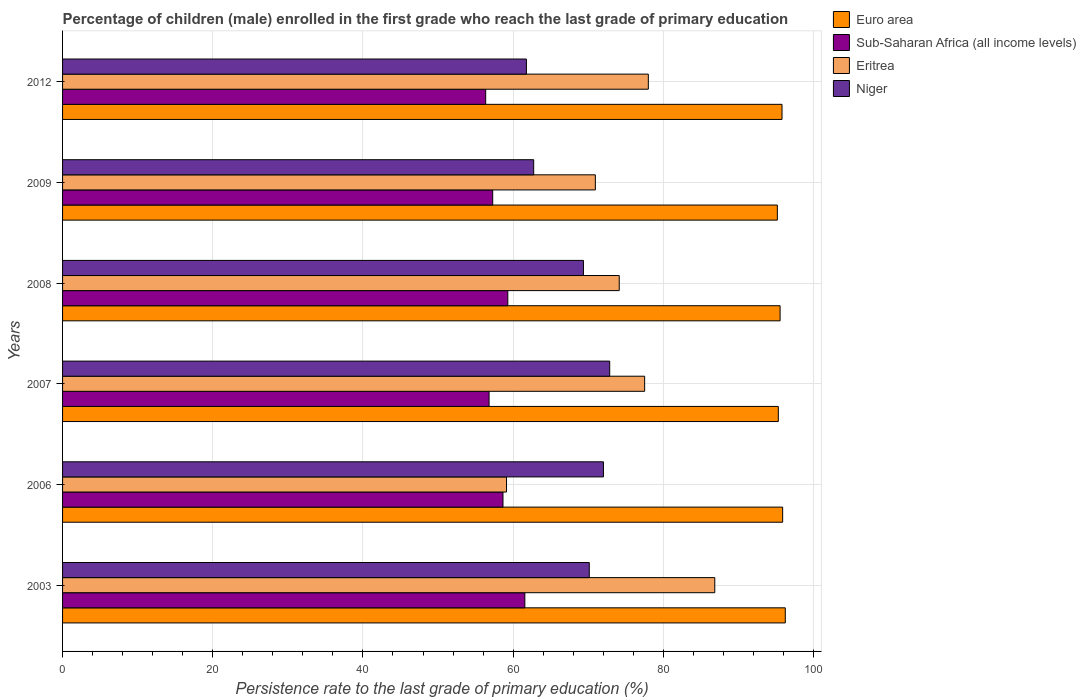How many groups of bars are there?
Your answer should be very brief. 6. Are the number of bars per tick equal to the number of legend labels?
Keep it short and to the point. Yes. How many bars are there on the 4th tick from the top?
Make the answer very short. 4. How many bars are there on the 4th tick from the bottom?
Your answer should be compact. 4. In how many cases, is the number of bars for a given year not equal to the number of legend labels?
Ensure brevity in your answer.  0. What is the persistence rate of children in Sub-Saharan Africa (all income levels) in 2009?
Offer a very short reply. 57.28. Across all years, what is the maximum persistence rate of children in Niger?
Offer a terse response. 72.86. Across all years, what is the minimum persistence rate of children in Euro area?
Offer a very short reply. 95.18. In which year was the persistence rate of children in Eritrea maximum?
Your answer should be compact. 2003. What is the total persistence rate of children in Euro area in the graph?
Your response must be concise. 573.97. What is the difference between the persistence rate of children in Sub-Saharan Africa (all income levels) in 2008 and that in 2009?
Your answer should be compact. 2.01. What is the difference between the persistence rate of children in Sub-Saharan Africa (all income levels) in 2006 and the persistence rate of children in Niger in 2008?
Your answer should be compact. -10.71. What is the average persistence rate of children in Niger per year?
Your answer should be compact. 68.15. In the year 2012, what is the difference between the persistence rate of children in Eritrea and persistence rate of children in Niger?
Your answer should be very brief. 16.23. What is the ratio of the persistence rate of children in Euro area in 2008 to that in 2012?
Offer a terse response. 1. Is the persistence rate of children in Euro area in 2007 less than that in 2008?
Provide a short and direct response. Yes. What is the difference between the highest and the second highest persistence rate of children in Niger?
Make the answer very short. 0.84. What is the difference between the highest and the lowest persistence rate of children in Niger?
Your answer should be compact. 11.09. In how many years, is the persistence rate of children in Niger greater than the average persistence rate of children in Niger taken over all years?
Ensure brevity in your answer.  4. Is the sum of the persistence rate of children in Sub-Saharan Africa (all income levels) in 2006 and 2012 greater than the maximum persistence rate of children in Euro area across all years?
Provide a short and direct response. Yes. Is it the case that in every year, the sum of the persistence rate of children in Eritrea and persistence rate of children in Euro area is greater than the sum of persistence rate of children in Niger and persistence rate of children in Sub-Saharan Africa (all income levels)?
Provide a succinct answer. Yes. What does the 2nd bar from the top in 2006 represents?
Give a very brief answer. Eritrea. What does the 2nd bar from the bottom in 2009 represents?
Provide a short and direct response. Sub-Saharan Africa (all income levels). Is it the case that in every year, the sum of the persistence rate of children in Sub-Saharan Africa (all income levels) and persistence rate of children in Niger is greater than the persistence rate of children in Eritrea?
Give a very brief answer. Yes. What is the difference between two consecutive major ticks on the X-axis?
Offer a very short reply. 20. Does the graph contain any zero values?
Your answer should be compact. No. How are the legend labels stacked?
Provide a short and direct response. Vertical. What is the title of the graph?
Your response must be concise. Percentage of children (male) enrolled in the first grade who reach the last grade of primary education. What is the label or title of the X-axis?
Your answer should be compact. Persistence rate to the last grade of primary education (%). What is the label or title of the Y-axis?
Provide a succinct answer. Years. What is the Persistence rate to the last grade of primary education (%) in Euro area in 2003?
Provide a succinct answer. 96.24. What is the Persistence rate to the last grade of primary education (%) of Sub-Saharan Africa (all income levels) in 2003?
Ensure brevity in your answer.  61.56. What is the Persistence rate to the last grade of primary education (%) in Eritrea in 2003?
Make the answer very short. 86.85. What is the Persistence rate to the last grade of primary education (%) of Niger in 2003?
Give a very brief answer. 70.14. What is the Persistence rate to the last grade of primary education (%) of Euro area in 2006?
Your answer should be very brief. 95.89. What is the Persistence rate to the last grade of primary education (%) in Sub-Saharan Africa (all income levels) in 2006?
Your answer should be very brief. 58.65. What is the Persistence rate to the last grade of primary education (%) in Eritrea in 2006?
Provide a succinct answer. 59.12. What is the Persistence rate to the last grade of primary education (%) of Niger in 2006?
Ensure brevity in your answer.  72.02. What is the Persistence rate to the last grade of primary education (%) in Euro area in 2007?
Provide a succinct answer. 95.31. What is the Persistence rate to the last grade of primary education (%) of Sub-Saharan Africa (all income levels) in 2007?
Offer a terse response. 56.8. What is the Persistence rate to the last grade of primary education (%) of Eritrea in 2007?
Keep it short and to the point. 77.51. What is the Persistence rate to the last grade of primary education (%) of Niger in 2007?
Your response must be concise. 72.86. What is the Persistence rate to the last grade of primary education (%) of Euro area in 2008?
Offer a very short reply. 95.55. What is the Persistence rate to the last grade of primary education (%) in Sub-Saharan Africa (all income levels) in 2008?
Your answer should be compact. 59.29. What is the Persistence rate to the last grade of primary education (%) in Eritrea in 2008?
Provide a succinct answer. 74.13. What is the Persistence rate to the last grade of primary education (%) of Niger in 2008?
Your answer should be very brief. 69.36. What is the Persistence rate to the last grade of primary education (%) of Euro area in 2009?
Provide a succinct answer. 95.18. What is the Persistence rate to the last grade of primary education (%) of Sub-Saharan Africa (all income levels) in 2009?
Provide a short and direct response. 57.28. What is the Persistence rate to the last grade of primary education (%) in Eritrea in 2009?
Offer a very short reply. 70.95. What is the Persistence rate to the last grade of primary education (%) in Niger in 2009?
Keep it short and to the point. 62.73. What is the Persistence rate to the last grade of primary education (%) of Euro area in 2012?
Your response must be concise. 95.8. What is the Persistence rate to the last grade of primary education (%) in Sub-Saharan Africa (all income levels) in 2012?
Offer a very short reply. 56.34. What is the Persistence rate to the last grade of primary education (%) in Eritrea in 2012?
Offer a very short reply. 78. What is the Persistence rate to the last grade of primary education (%) in Niger in 2012?
Your answer should be very brief. 61.77. Across all years, what is the maximum Persistence rate to the last grade of primary education (%) of Euro area?
Give a very brief answer. 96.24. Across all years, what is the maximum Persistence rate to the last grade of primary education (%) of Sub-Saharan Africa (all income levels)?
Offer a very short reply. 61.56. Across all years, what is the maximum Persistence rate to the last grade of primary education (%) in Eritrea?
Give a very brief answer. 86.85. Across all years, what is the maximum Persistence rate to the last grade of primary education (%) of Niger?
Provide a succinct answer. 72.86. Across all years, what is the minimum Persistence rate to the last grade of primary education (%) of Euro area?
Ensure brevity in your answer.  95.18. Across all years, what is the minimum Persistence rate to the last grade of primary education (%) of Sub-Saharan Africa (all income levels)?
Offer a very short reply. 56.34. Across all years, what is the minimum Persistence rate to the last grade of primary education (%) in Eritrea?
Your answer should be very brief. 59.12. Across all years, what is the minimum Persistence rate to the last grade of primary education (%) of Niger?
Give a very brief answer. 61.77. What is the total Persistence rate to the last grade of primary education (%) of Euro area in the graph?
Give a very brief answer. 573.97. What is the total Persistence rate to the last grade of primary education (%) in Sub-Saharan Africa (all income levels) in the graph?
Give a very brief answer. 349.91. What is the total Persistence rate to the last grade of primary education (%) of Eritrea in the graph?
Your answer should be compact. 446.55. What is the total Persistence rate to the last grade of primary education (%) in Niger in the graph?
Your response must be concise. 408.88. What is the difference between the Persistence rate to the last grade of primary education (%) in Euro area in 2003 and that in 2006?
Your answer should be very brief. 0.35. What is the difference between the Persistence rate to the last grade of primary education (%) of Sub-Saharan Africa (all income levels) in 2003 and that in 2006?
Your answer should be compact. 2.91. What is the difference between the Persistence rate to the last grade of primary education (%) in Eritrea in 2003 and that in 2006?
Provide a short and direct response. 27.73. What is the difference between the Persistence rate to the last grade of primary education (%) in Niger in 2003 and that in 2006?
Offer a very short reply. -1.89. What is the difference between the Persistence rate to the last grade of primary education (%) in Euro area in 2003 and that in 2007?
Offer a very short reply. 0.93. What is the difference between the Persistence rate to the last grade of primary education (%) in Sub-Saharan Africa (all income levels) in 2003 and that in 2007?
Your response must be concise. 4.76. What is the difference between the Persistence rate to the last grade of primary education (%) of Eritrea in 2003 and that in 2007?
Provide a short and direct response. 9.34. What is the difference between the Persistence rate to the last grade of primary education (%) of Niger in 2003 and that in 2007?
Keep it short and to the point. -2.72. What is the difference between the Persistence rate to the last grade of primary education (%) in Euro area in 2003 and that in 2008?
Provide a succinct answer. 0.69. What is the difference between the Persistence rate to the last grade of primary education (%) in Sub-Saharan Africa (all income levels) in 2003 and that in 2008?
Your answer should be very brief. 2.27. What is the difference between the Persistence rate to the last grade of primary education (%) of Eritrea in 2003 and that in 2008?
Your response must be concise. 12.72. What is the difference between the Persistence rate to the last grade of primary education (%) of Niger in 2003 and that in 2008?
Ensure brevity in your answer.  0.78. What is the difference between the Persistence rate to the last grade of primary education (%) in Euro area in 2003 and that in 2009?
Your answer should be compact. 1.06. What is the difference between the Persistence rate to the last grade of primary education (%) in Sub-Saharan Africa (all income levels) in 2003 and that in 2009?
Offer a very short reply. 4.28. What is the difference between the Persistence rate to the last grade of primary education (%) in Eritrea in 2003 and that in 2009?
Your answer should be very brief. 15.9. What is the difference between the Persistence rate to the last grade of primary education (%) in Niger in 2003 and that in 2009?
Make the answer very short. 7.4. What is the difference between the Persistence rate to the last grade of primary education (%) of Euro area in 2003 and that in 2012?
Offer a terse response. 0.43. What is the difference between the Persistence rate to the last grade of primary education (%) in Sub-Saharan Africa (all income levels) in 2003 and that in 2012?
Make the answer very short. 5.21. What is the difference between the Persistence rate to the last grade of primary education (%) in Eritrea in 2003 and that in 2012?
Provide a succinct answer. 8.85. What is the difference between the Persistence rate to the last grade of primary education (%) of Niger in 2003 and that in 2012?
Ensure brevity in your answer.  8.37. What is the difference between the Persistence rate to the last grade of primary education (%) in Euro area in 2006 and that in 2007?
Offer a terse response. 0.58. What is the difference between the Persistence rate to the last grade of primary education (%) in Sub-Saharan Africa (all income levels) in 2006 and that in 2007?
Provide a succinct answer. 1.85. What is the difference between the Persistence rate to the last grade of primary education (%) of Eritrea in 2006 and that in 2007?
Your response must be concise. -18.39. What is the difference between the Persistence rate to the last grade of primary education (%) of Niger in 2006 and that in 2007?
Your response must be concise. -0.84. What is the difference between the Persistence rate to the last grade of primary education (%) of Euro area in 2006 and that in 2008?
Keep it short and to the point. 0.34. What is the difference between the Persistence rate to the last grade of primary education (%) of Sub-Saharan Africa (all income levels) in 2006 and that in 2008?
Ensure brevity in your answer.  -0.64. What is the difference between the Persistence rate to the last grade of primary education (%) in Eritrea in 2006 and that in 2008?
Keep it short and to the point. -15.01. What is the difference between the Persistence rate to the last grade of primary education (%) of Niger in 2006 and that in 2008?
Give a very brief answer. 2.66. What is the difference between the Persistence rate to the last grade of primary education (%) of Euro area in 2006 and that in 2009?
Make the answer very short. 0.71. What is the difference between the Persistence rate to the last grade of primary education (%) in Sub-Saharan Africa (all income levels) in 2006 and that in 2009?
Your answer should be very brief. 1.37. What is the difference between the Persistence rate to the last grade of primary education (%) in Eritrea in 2006 and that in 2009?
Provide a succinct answer. -11.83. What is the difference between the Persistence rate to the last grade of primary education (%) of Niger in 2006 and that in 2009?
Offer a terse response. 9.29. What is the difference between the Persistence rate to the last grade of primary education (%) of Euro area in 2006 and that in 2012?
Keep it short and to the point. 0.08. What is the difference between the Persistence rate to the last grade of primary education (%) of Sub-Saharan Africa (all income levels) in 2006 and that in 2012?
Make the answer very short. 2.3. What is the difference between the Persistence rate to the last grade of primary education (%) in Eritrea in 2006 and that in 2012?
Provide a short and direct response. -18.88. What is the difference between the Persistence rate to the last grade of primary education (%) in Niger in 2006 and that in 2012?
Ensure brevity in your answer.  10.26. What is the difference between the Persistence rate to the last grade of primary education (%) of Euro area in 2007 and that in 2008?
Your answer should be very brief. -0.24. What is the difference between the Persistence rate to the last grade of primary education (%) in Sub-Saharan Africa (all income levels) in 2007 and that in 2008?
Provide a short and direct response. -2.5. What is the difference between the Persistence rate to the last grade of primary education (%) in Eritrea in 2007 and that in 2008?
Your answer should be very brief. 3.38. What is the difference between the Persistence rate to the last grade of primary education (%) of Niger in 2007 and that in 2008?
Your response must be concise. 3.5. What is the difference between the Persistence rate to the last grade of primary education (%) in Euro area in 2007 and that in 2009?
Ensure brevity in your answer.  0.13. What is the difference between the Persistence rate to the last grade of primary education (%) in Sub-Saharan Africa (all income levels) in 2007 and that in 2009?
Offer a very short reply. -0.48. What is the difference between the Persistence rate to the last grade of primary education (%) in Eritrea in 2007 and that in 2009?
Give a very brief answer. 6.56. What is the difference between the Persistence rate to the last grade of primary education (%) of Niger in 2007 and that in 2009?
Your answer should be very brief. 10.12. What is the difference between the Persistence rate to the last grade of primary education (%) in Euro area in 2007 and that in 2012?
Ensure brevity in your answer.  -0.49. What is the difference between the Persistence rate to the last grade of primary education (%) of Sub-Saharan Africa (all income levels) in 2007 and that in 2012?
Provide a succinct answer. 0.45. What is the difference between the Persistence rate to the last grade of primary education (%) in Eritrea in 2007 and that in 2012?
Ensure brevity in your answer.  -0.49. What is the difference between the Persistence rate to the last grade of primary education (%) in Niger in 2007 and that in 2012?
Keep it short and to the point. 11.09. What is the difference between the Persistence rate to the last grade of primary education (%) of Euro area in 2008 and that in 2009?
Your answer should be compact. 0.37. What is the difference between the Persistence rate to the last grade of primary education (%) in Sub-Saharan Africa (all income levels) in 2008 and that in 2009?
Keep it short and to the point. 2.01. What is the difference between the Persistence rate to the last grade of primary education (%) of Eritrea in 2008 and that in 2009?
Your answer should be very brief. 3.18. What is the difference between the Persistence rate to the last grade of primary education (%) in Niger in 2008 and that in 2009?
Make the answer very short. 6.63. What is the difference between the Persistence rate to the last grade of primary education (%) of Euro area in 2008 and that in 2012?
Your answer should be compact. -0.26. What is the difference between the Persistence rate to the last grade of primary education (%) in Sub-Saharan Africa (all income levels) in 2008 and that in 2012?
Offer a very short reply. 2.95. What is the difference between the Persistence rate to the last grade of primary education (%) in Eritrea in 2008 and that in 2012?
Offer a terse response. -3.87. What is the difference between the Persistence rate to the last grade of primary education (%) of Niger in 2008 and that in 2012?
Your response must be concise. 7.59. What is the difference between the Persistence rate to the last grade of primary education (%) in Euro area in 2009 and that in 2012?
Offer a terse response. -0.62. What is the difference between the Persistence rate to the last grade of primary education (%) in Sub-Saharan Africa (all income levels) in 2009 and that in 2012?
Offer a terse response. 0.93. What is the difference between the Persistence rate to the last grade of primary education (%) in Eritrea in 2009 and that in 2012?
Provide a short and direct response. -7.06. What is the difference between the Persistence rate to the last grade of primary education (%) in Niger in 2009 and that in 2012?
Your response must be concise. 0.97. What is the difference between the Persistence rate to the last grade of primary education (%) of Euro area in 2003 and the Persistence rate to the last grade of primary education (%) of Sub-Saharan Africa (all income levels) in 2006?
Your answer should be compact. 37.59. What is the difference between the Persistence rate to the last grade of primary education (%) in Euro area in 2003 and the Persistence rate to the last grade of primary education (%) in Eritrea in 2006?
Your answer should be compact. 37.12. What is the difference between the Persistence rate to the last grade of primary education (%) in Euro area in 2003 and the Persistence rate to the last grade of primary education (%) in Niger in 2006?
Keep it short and to the point. 24.21. What is the difference between the Persistence rate to the last grade of primary education (%) of Sub-Saharan Africa (all income levels) in 2003 and the Persistence rate to the last grade of primary education (%) of Eritrea in 2006?
Provide a succinct answer. 2.44. What is the difference between the Persistence rate to the last grade of primary education (%) in Sub-Saharan Africa (all income levels) in 2003 and the Persistence rate to the last grade of primary education (%) in Niger in 2006?
Give a very brief answer. -10.47. What is the difference between the Persistence rate to the last grade of primary education (%) in Eritrea in 2003 and the Persistence rate to the last grade of primary education (%) in Niger in 2006?
Provide a short and direct response. 14.83. What is the difference between the Persistence rate to the last grade of primary education (%) of Euro area in 2003 and the Persistence rate to the last grade of primary education (%) of Sub-Saharan Africa (all income levels) in 2007?
Your answer should be very brief. 39.44. What is the difference between the Persistence rate to the last grade of primary education (%) of Euro area in 2003 and the Persistence rate to the last grade of primary education (%) of Eritrea in 2007?
Your response must be concise. 18.73. What is the difference between the Persistence rate to the last grade of primary education (%) of Euro area in 2003 and the Persistence rate to the last grade of primary education (%) of Niger in 2007?
Your answer should be very brief. 23.38. What is the difference between the Persistence rate to the last grade of primary education (%) of Sub-Saharan Africa (all income levels) in 2003 and the Persistence rate to the last grade of primary education (%) of Eritrea in 2007?
Offer a very short reply. -15.95. What is the difference between the Persistence rate to the last grade of primary education (%) in Sub-Saharan Africa (all income levels) in 2003 and the Persistence rate to the last grade of primary education (%) in Niger in 2007?
Offer a very short reply. -11.3. What is the difference between the Persistence rate to the last grade of primary education (%) in Eritrea in 2003 and the Persistence rate to the last grade of primary education (%) in Niger in 2007?
Your answer should be very brief. 13.99. What is the difference between the Persistence rate to the last grade of primary education (%) in Euro area in 2003 and the Persistence rate to the last grade of primary education (%) in Sub-Saharan Africa (all income levels) in 2008?
Your answer should be compact. 36.95. What is the difference between the Persistence rate to the last grade of primary education (%) in Euro area in 2003 and the Persistence rate to the last grade of primary education (%) in Eritrea in 2008?
Your response must be concise. 22.11. What is the difference between the Persistence rate to the last grade of primary education (%) in Euro area in 2003 and the Persistence rate to the last grade of primary education (%) in Niger in 2008?
Give a very brief answer. 26.88. What is the difference between the Persistence rate to the last grade of primary education (%) in Sub-Saharan Africa (all income levels) in 2003 and the Persistence rate to the last grade of primary education (%) in Eritrea in 2008?
Keep it short and to the point. -12.57. What is the difference between the Persistence rate to the last grade of primary education (%) of Sub-Saharan Africa (all income levels) in 2003 and the Persistence rate to the last grade of primary education (%) of Niger in 2008?
Provide a short and direct response. -7.8. What is the difference between the Persistence rate to the last grade of primary education (%) of Eritrea in 2003 and the Persistence rate to the last grade of primary education (%) of Niger in 2008?
Your response must be concise. 17.49. What is the difference between the Persistence rate to the last grade of primary education (%) of Euro area in 2003 and the Persistence rate to the last grade of primary education (%) of Sub-Saharan Africa (all income levels) in 2009?
Ensure brevity in your answer.  38.96. What is the difference between the Persistence rate to the last grade of primary education (%) of Euro area in 2003 and the Persistence rate to the last grade of primary education (%) of Eritrea in 2009?
Offer a terse response. 25.29. What is the difference between the Persistence rate to the last grade of primary education (%) of Euro area in 2003 and the Persistence rate to the last grade of primary education (%) of Niger in 2009?
Provide a short and direct response. 33.5. What is the difference between the Persistence rate to the last grade of primary education (%) in Sub-Saharan Africa (all income levels) in 2003 and the Persistence rate to the last grade of primary education (%) in Eritrea in 2009?
Your response must be concise. -9.39. What is the difference between the Persistence rate to the last grade of primary education (%) of Sub-Saharan Africa (all income levels) in 2003 and the Persistence rate to the last grade of primary education (%) of Niger in 2009?
Your response must be concise. -1.18. What is the difference between the Persistence rate to the last grade of primary education (%) in Eritrea in 2003 and the Persistence rate to the last grade of primary education (%) in Niger in 2009?
Give a very brief answer. 24.12. What is the difference between the Persistence rate to the last grade of primary education (%) of Euro area in 2003 and the Persistence rate to the last grade of primary education (%) of Sub-Saharan Africa (all income levels) in 2012?
Ensure brevity in your answer.  39.89. What is the difference between the Persistence rate to the last grade of primary education (%) of Euro area in 2003 and the Persistence rate to the last grade of primary education (%) of Eritrea in 2012?
Offer a terse response. 18.24. What is the difference between the Persistence rate to the last grade of primary education (%) in Euro area in 2003 and the Persistence rate to the last grade of primary education (%) in Niger in 2012?
Your answer should be compact. 34.47. What is the difference between the Persistence rate to the last grade of primary education (%) in Sub-Saharan Africa (all income levels) in 2003 and the Persistence rate to the last grade of primary education (%) in Eritrea in 2012?
Offer a very short reply. -16.44. What is the difference between the Persistence rate to the last grade of primary education (%) of Sub-Saharan Africa (all income levels) in 2003 and the Persistence rate to the last grade of primary education (%) of Niger in 2012?
Your response must be concise. -0.21. What is the difference between the Persistence rate to the last grade of primary education (%) in Eritrea in 2003 and the Persistence rate to the last grade of primary education (%) in Niger in 2012?
Keep it short and to the point. 25.08. What is the difference between the Persistence rate to the last grade of primary education (%) of Euro area in 2006 and the Persistence rate to the last grade of primary education (%) of Sub-Saharan Africa (all income levels) in 2007?
Provide a short and direct response. 39.09. What is the difference between the Persistence rate to the last grade of primary education (%) of Euro area in 2006 and the Persistence rate to the last grade of primary education (%) of Eritrea in 2007?
Give a very brief answer. 18.38. What is the difference between the Persistence rate to the last grade of primary education (%) of Euro area in 2006 and the Persistence rate to the last grade of primary education (%) of Niger in 2007?
Your answer should be very brief. 23.03. What is the difference between the Persistence rate to the last grade of primary education (%) in Sub-Saharan Africa (all income levels) in 2006 and the Persistence rate to the last grade of primary education (%) in Eritrea in 2007?
Offer a terse response. -18.86. What is the difference between the Persistence rate to the last grade of primary education (%) of Sub-Saharan Africa (all income levels) in 2006 and the Persistence rate to the last grade of primary education (%) of Niger in 2007?
Make the answer very short. -14.21. What is the difference between the Persistence rate to the last grade of primary education (%) in Eritrea in 2006 and the Persistence rate to the last grade of primary education (%) in Niger in 2007?
Make the answer very short. -13.74. What is the difference between the Persistence rate to the last grade of primary education (%) of Euro area in 2006 and the Persistence rate to the last grade of primary education (%) of Sub-Saharan Africa (all income levels) in 2008?
Offer a very short reply. 36.6. What is the difference between the Persistence rate to the last grade of primary education (%) in Euro area in 2006 and the Persistence rate to the last grade of primary education (%) in Eritrea in 2008?
Make the answer very short. 21.76. What is the difference between the Persistence rate to the last grade of primary education (%) of Euro area in 2006 and the Persistence rate to the last grade of primary education (%) of Niger in 2008?
Your answer should be very brief. 26.53. What is the difference between the Persistence rate to the last grade of primary education (%) in Sub-Saharan Africa (all income levels) in 2006 and the Persistence rate to the last grade of primary education (%) in Eritrea in 2008?
Make the answer very short. -15.48. What is the difference between the Persistence rate to the last grade of primary education (%) in Sub-Saharan Africa (all income levels) in 2006 and the Persistence rate to the last grade of primary education (%) in Niger in 2008?
Keep it short and to the point. -10.71. What is the difference between the Persistence rate to the last grade of primary education (%) in Eritrea in 2006 and the Persistence rate to the last grade of primary education (%) in Niger in 2008?
Ensure brevity in your answer.  -10.24. What is the difference between the Persistence rate to the last grade of primary education (%) in Euro area in 2006 and the Persistence rate to the last grade of primary education (%) in Sub-Saharan Africa (all income levels) in 2009?
Ensure brevity in your answer.  38.61. What is the difference between the Persistence rate to the last grade of primary education (%) of Euro area in 2006 and the Persistence rate to the last grade of primary education (%) of Eritrea in 2009?
Your answer should be very brief. 24.94. What is the difference between the Persistence rate to the last grade of primary education (%) in Euro area in 2006 and the Persistence rate to the last grade of primary education (%) in Niger in 2009?
Ensure brevity in your answer.  33.15. What is the difference between the Persistence rate to the last grade of primary education (%) in Sub-Saharan Africa (all income levels) in 2006 and the Persistence rate to the last grade of primary education (%) in Eritrea in 2009?
Keep it short and to the point. -12.3. What is the difference between the Persistence rate to the last grade of primary education (%) in Sub-Saharan Africa (all income levels) in 2006 and the Persistence rate to the last grade of primary education (%) in Niger in 2009?
Your response must be concise. -4.09. What is the difference between the Persistence rate to the last grade of primary education (%) in Eritrea in 2006 and the Persistence rate to the last grade of primary education (%) in Niger in 2009?
Ensure brevity in your answer.  -3.62. What is the difference between the Persistence rate to the last grade of primary education (%) of Euro area in 2006 and the Persistence rate to the last grade of primary education (%) of Sub-Saharan Africa (all income levels) in 2012?
Offer a terse response. 39.54. What is the difference between the Persistence rate to the last grade of primary education (%) in Euro area in 2006 and the Persistence rate to the last grade of primary education (%) in Eritrea in 2012?
Give a very brief answer. 17.89. What is the difference between the Persistence rate to the last grade of primary education (%) of Euro area in 2006 and the Persistence rate to the last grade of primary education (%) of Niger in 2012?
Your answer should be compact. 34.12. What is the difference between the Persistence rate to the last grade of primary education (%) of Sub-Saharan Africa (all income levels) in 2006 and the Persistence rate to the last grade of primary education (%) of Eritrea in 2012?
Give a very brief answer. -19.35. What is the difference between the Persistence rate to the last grade of primary education (%) of Sub-Saharan Africa (all income levels) in 2006 and the Persistence rate to the last grade of primary education (%) of Niger in 2012?
Offer a terse response. -3.12. What is the difference between the Persistence rate to the last grade of primary education (%) of Eritrea in 2006 and the Persistence rate to the last grade of primary education (%) of Niger in 2012?
Make the answer very short. -2.65. What is the difference between the Persistence rate to the last grade of primary education (%) of Euro area in 2007 and the Persistence rate to the last grade of primary education (%) of Sub-Saharan Africa (all income levels) in 2008?
Provide a short and direct response. 36.02. What is the difference between the Persistence rate to the last grade of primary education (%) in Euro area in 2007 and the Persistence rate to the last grade of primary education (%) in Eritrea in 2008?
Your response must be concise. 21.18. What is the difference between the Persistence rate to the last grade of primary education (%) in Euro area in 2007 and the Persistence rate to the last grade of primary education (%) in Niger in 2008?
Offer a terse response. 25.95. What is the difference between the Persistence rate to the last grade of primary education (%) of Sub-Saharan Africa (all income levels) in 2007 and the Persistence rate to the last grade of primary education (%) of Eritrea in 2008?
Your response must be concise. -17.33. What is the difference between the Persistence rate to the last grade of primary education (%) of Sub-Saharan Africa (all income levels) in 2007 and the Persistence rate to the last grade of primary education (%) of Niger in 2008?
Ensure brevity in your answer.  -12.57. What is the difference between the Persistence rate to the last grade of primary education (%) of Eritrea in 2007 and the Persistence rate to the last grade of primary education (%) of Niger in 2008?
Provide a succinct answer. 8.15. What is the difference between the Persistence rate to the last grade of primary education (%) of Euro area in 2007 and the Persistence rate to the last grade of primary education (%) of Sub-Saharan Africa (all income levels) in 2009?
Your answer should be compact. 38.03. What is the difference between the Persistence rate to the last grade of primary education (%) of Euro area in 2007 and the Persistence rate to the last grade of primary education (%) of Eritrea in 2009?
Your response must be concise. 24.36. What is the difference between the Persistence rate to the last grade of primary education (%) of Euro area in 2007 and the Persistence rate to the last grade of primary education (%) of Niger in 2009?
Make the answer very short. 32.58. What is the difference between the Persistence rate to the last grade of primary education (%) in Sub-Saharan Africa (all income levels) in 2007 and the Persistence rate to the last grade of primary education (%) in Eritrea in 2009?
Provide a succinct answer. -14.15. What is the difference between the Persistence rate to the last grade of primary education (%) in Sub-Saharan Africa (all income levels) in 2007 and the Persistence rate to the last grade of primary education (%) in Niger in 2009?
Make the answer very short. -5.94. What is the difference between the Persistence rate to the last grade of primary education (%) in Eritrea in 2007 and the Persistence rate to the last grade of primary education (%) in Niger in 2009?
Provide a succinct answer. 14.78. What is the difference between the Persistence rate to the last grade of primary education (%) of Euro area in 2007 and the Persistence rate to the last grade of primary education (%) of Sub-Saharan Africa (all income levels) in 2012?
Make the answer very short. 38.97. What is the difference between the Persistence rate to the last grade of primary education (%) in Euro area in 2007 and the Persistence rate to the last grade of primary education (%) in Eritrea in 2012?
Provide a succinct answer. 17.31. What is the difference between the Persistence rate to the last grade of primary education (%) of Euro area in 2007 and the Persistence rate to the last grade of primary education (%) of Niger in 2012?
Provide a short and direct response. 33.54. What is the difference between the Persistence rate to the last grade of primary education (%) in Sub-Saharan Africa (all income levels) in 2007 and the Persistence rate to the last grade of primary education (%) in Eritrea in 2012?
Offer a very short reply. -21.21. What is the difference between the Persistence rate to the last grade of primary education (%) of Sub-Saharan Africa (all income levels) in 2007 and the Persistence rate to the last grade of primary education (%) of Niger in 2012?
Give a very brief answer. -4.97. What is the difference between the Persistence rate to the last grade of primary education (%) in Eritrea in 2007 and the Persistence rate to the last grade of primary education (%) in Niger in 2012?
Your response must be concise. 15.74. What is the difference between the Persistence rate to the last grade of primary education (%) of Euro area in 2008 and the Persistence rate to the last grade of primary education (%) of Sub-Saharan Africa (all income levels) in 2009?
Keep it short and to the point. 38.27. What is the difference between the Persistence rate to the last grade of primary education (%) of Euro area in 2008 and the Persistence rate to the last grade of primary education (%) of Eritrea in 2009?
Your answer should be very brief. 24.6. What is the difference between the Persistence rate to the last grade of primary education (%) in Euro area in 2008 and the Persistence rate to the last grade of primary education (%) in Niger in 2009?
Your answer should be very brief. 32.81. What is the difference between the Persistence rate to the last grade of primary education (%) of Sub-Saharan Africa (all income levels) in 2008 and the Persistence rate to the last grade of primary education (%) of Eritrea in 2009?
Your response must be concise. -11.66. What is the difference between the Persistence rate to the last grade of primary education (%) of Sub-Saharan Africa (all income levels) in 2008 and the Persistence rate to the last grade of primary education (%) of Niger in 2009?
Give a very brief answer. -3.44. What is the difference between the Persistence rate to the last grade of primary education (%) of Eritrea in 2008 and the Persistence rate to the last grade of primary education (%) of Niger in 2009?
Offer a very short reply. 11.39. What is the difference between the Persistence rate to the last grade of primary education (%) of Euro area in 2008 and the Persistence rate to the last grade of primary education (%) of Sub-Saharan Africa (all income levels) in 2012?
Provide a short and direct response. 39.2. What is the difference between the Persistence rate to the last grade of primary education (%) in Euro area in 2008 and the Persistence rate to the last grade of primary education (%) in Eritrea in 2012?
Provide a succinct answer. 17.55. What is the difference between the Persistence rate to the last grade of primary education (%) in Euro area in 2008 and the Persistence rate to the last grade of primary education (%) in Niger in 2012?
Provide a short and direct response. 33.78. What is the difference between the Persistence rate to the last grade of primary education (%) of Sub-Saharan Africa (all income levels) in 2008 and the Persistence rate to the last grade of primary education (%) of Eritrea in 2012?
Ensure brevity in your answer.  -18.71. What is the difference between the Persistence rate to the last grade of primary education (%) in Sub-Saharan Africa (all income levels) in 2008 and the Persistence rate to the last grade of primary education (%) in Niger in 2012?
Ensure brevity in your answer.  -2.48. What is the difference between the Persistence rate to the last grade of primary education (%) of Eritrea in 2008 and the Persistence rate to the last grade of primary education (%) of Niger in 2012?
Your answer should be very brief. 12.36. What is the difference between the Persistence rate to the last grade of primary education (%) in Euro area in 2009 and the Persistence rate to the last grade of primary education (%) in Sub-Saharan Africa (all income levels) in 2012?
Your answer should be compact. 38.84. What is the difference between the Persistence rate to the last grade of primary education (%) in Euro area in 2009 and the Persistence rate to the last grade of primary education (%) in Eritrea in 2012?
Provide a succinct answer. 17.18. What is the difference between the Persistence rate to the last grade of primary education (%) of Euro area in 2009 and the Persistence rate to the last grade of primary education (%) of Niger in 2012?
Give a very brief answer. 33.41. What is the difference between the Persistence rate to the last grade of primary education (%) in Sub-Saharan Africa (all income levels) in 2009 and the Persistence rate to the last grade of primary education (%) in Eritrea in 2012?
Provide a short and direct response. -20.72. What is the difference between the Persistence rate to the last grade of primary education (%) of Sub-Saharan Africa (all income levels) in 2009 and the Persistence rate to the last grade of primary education (%) of Niger in 2012?
Your response must be concise. -4.49. What is the difference between the Persistence rate to the last grade of primary education (%) in Eritrea in 2009 and the Persistence rate to the last grade of primary education (%) in Niger in 2012?
Give a very brief answer. 9.18. What is the average Persistence rate to the last grade of primary education (%) in Euro area per year?
Offer a terse response. 95.66. What is the average Persistence rate to the last grade of primary education (%) of Sub-Saharan Africa (all income levels) per year?
Offer a terse response. 58.32. What is the average Persistence rate to the last grade of primary education (%) in Eritrea per year?
Your answer should be compact. 74.43. What is the average Persistence rate to the last grade of primary education (%) of Niger per year?
Provide a succinct answer. 68.15. In the year 2003, what is the difference between the Persistence rate to the last grade of primary education (%) of Euro area and Persistence rate to the last grade of primary education (%) of Sub-Saharan Africa (all income levels)?
Provide a succinct answer. 34.68. In the year 2003, what is the difference between the Persistence rate to the last grade of primary education (%) in Euro area and Persistence rate to the last grade of primary education (%) in Eritrea?
Your response must be concise. 9.39. In the year 2003, what is the difference between the Persistence rate to the last grade of primary education (%) of Euro area and Persistence rate to the last grade of primary education (%) of Niger?
Offer a terse response. 26.1. In the year 2003, what is the difference between the Persistence rate to the last grade of primary education (%) in Sub-Saharan Africa (all income levels) and Persistence rate to the last grade of primary education (%) in Eritrea?
Ensure brevity in your answer.  -25.29. In the year 2003, what is the difference between the Persistence rate to the last grade of primary education (%) in Sub-Saharan Africa (all income levels) and Persistence rate to the last grade of primary education (%) in Niger?
Your response must be concise. -8.58. In the year 2003, what is the difference between the Persistence rate to the last grade of primary education (%) in Eritrea and Persistence rate to the last grade of primary education (%) in Niger?
Your response must be concise. 16.71. In the year 2006, what is the difference between the Persistence rate to the last grade of primary education (%) in Euro area and Persistence rate to the last grade of primary education (%) in Sub-Saharan Africa (all income levels)?
Ensure brevity in your answer.  37.24. In the year 2006, what is the difference between the Persistence rate to the last grade of primary education (%) in Euro area and Persistence rate to the last grade of primary education (%) in Eritrea?
Keep it short and to the point. 36.77. In the year 2006, what is the difference between the Persistence rate to the last grade of primary education (%) in Euro area and Persistence rate to the last grade of primary education (%) in Niger?
Provide a short and direct response. 23.86. In the year 2006, what is the difference between the Persistence rate to the last grade of primary education (%) in Sub-Saharan Africa (all income levels) and Persistence rate to the last grade of primary education (%) in Eritrea?
Keep it short and to the point. -0.47. In the year 2006, what is the difference between the Persistence rate to the last grade of primary education (%) of Sub-Saharan Africa (all income levels) and Persistence rate to the last grade of primary education (%) of Niger?
Your answer should be very brief. -13.38. In the year 2006, what is the difference between the Persistence rate to the last grade of primary education (%) of Eritrea and Persistence rate to the last grade of primary education (%) of Niger?
Your answer should be very brief. -12.9. In the year 2007, what is the difference between the Persistence rate to the last grade of primary education (%) of Euro area and Persistence rate to the last grade of primary education (%) of Sub-Saharan Africa (all income levels)?
Your answer should be compact. 38.51. In the year 2007, what is the difference between the Persistence rate to the last grade of primary education (%) of Euro area and Persistence rate to the last grade of primary education (%) of Eritrea?
Provide a short and direct response. 17.8. In the year 2007, what is the difference between the Persistence rate to the last grade of primary education (%) in Euro area and Persistence rate to the last grade of primary education (%) in Niger?
Make the answer very short. 22.45. In the year 2007, what is the difference between the Persistence rate to the last grade of primary education (%) in Sub-Saharan Africa (all income levels) and Persistence rate to the last grade of primary education (%) in Eritrea?
Give a very brief answer. -20.71. In the year 2007, what is the difference between the Persistence rate to the last grade of primary education (%) in Sub-Saharan Africa (all income levels) and Persistence rate to the last grade of primary education (%) in Niger?
Your response must be concise. -16.06. In the year 2007, what is the difference between the Persistence rate to the last grade of primary education (%) in Eritrea and Persistence rate to the last grade of primary education (%) in Niger?
Provide a short and direct response. 4.65. In the year 2008, what is the difference between the Persistence rate to the last grade of primary education (%) of Euro area and Persistence rate to the last grade of primary education (%) of Sub-Saharan Africa (all income levels)?
Offer a terse response. 36.26. In the year 2008, what is the difference between the Persistence rate to the last grade of primary education (%) in Euro area and Persistence rate to the last grade of primary education (%) in Eritrea?
Your response must be concise. 21.42. In the year 2008, what is the difference between the Persistence rate to the last grade of primary education (%) of Euro area and Persistence rate to the last grade of primary education (%) of Niger?
Ensure brevity in your answer.  26.18. In the year 2008, what is the difference between the Persistence rate to the last grade of primary education (%) of Sub-Saharan Africa (all income levels) and Persistence rate to the last grade of primary education (%) of Eritrea?
Offer a very short reply. -14.84. In the year 2008, what is the difference between the Persistence rate to the last grade of primary education (%) of Sub-Saharan Africa (all income levels) and Persistence rate to the last grade of primary education (%) of Niger?
Offer a very short reply. -10.07. In the year 2008, what is the difference between the Persistence rate to the last grade of primary education (%) of Eritrea and Persistence rate to the last grade of primary education (%) of Niger?
Offer a terse response. 4.76. In the year 2009, what is the difference between the Persistence rate to the last grade of primary education (%) in Euro area and Persistence rate to the last grade of primary education (%) in Sub-Saharan Africa (all income levels)?
Your answer should be very brief. 37.9. In the year 2009, what is the difference between the Persistence rate to the last grade of primary education (%) in Euro area and Persistence rate to the last grade of primary education (%) in Eritrea?
Make the answer very short. 24.24. In the year 2009, what is the difference between the Persistence rate to the last grade of primary education (%) of Euro area and Persistence rate to the last grade of primary education (%) of Niger?
Your answer should be very brief. 32.45. In the year 2009, what is the difference between the Persistence rate to the last grade of primary education (%) in Sub-Saharan Africa (all income levels) and Persistence rate to the last grade of primary education (%) in Eritrea?
Your response must be concise. -13.67. In the year 2009, what is the difference between the Persistence rate to the last grade of primary education (%) in Sub-Saharan Africa (all income levels) and Persistence rate to the last grade of primary education (%) in Niger?
Keep it short and to the point. -5.46. In the year 2009, what is the difference between the Persistence rate to the last grade of primary education (%) in Eritrea and Persistence rate to the last grade of primary education (%) in Niger?
Your answer should be very brief. 8.21. In the year 2012, what is the difference between the Persistence rate to the last grade of primary education (%) of Euro area and Persistence rate to the last grade of primary education (%) of Sub-Saharan Africa (all income levels)?
Offer a terse response. 39.46. In the year 2012, what is the difference between the Persistence rate to the last grade of primary education (%) of Euro area and Persistence rate to the last grade of primary education (%) of Eritrea?
Keep it short and to the point. 17.8. In the year 2012, what is the difference between the Persistence rate to the last grade of primary education (%) of Euro area and Persistence rate to the last grade of primary education (%) of Niger?
Offer a terse response. 34.04. In the year 2012, what is the difference between the Persistence rate to the last grade of primary education (%) in Sub-Saharan Africa (all income levels) and Persistence rate to the last grade of primary education (%) in Eritrea?
Your answer should be compact. -21.66. In the year 2012, what is the difference between the Persistence rate to the last grade of primary education (%) of Sub-Saharan Africa (all income levels) and Persistence rate to the last grade of primary education (%) of Niger?
Provide a short and direct response. -5.42. In the year 2012, what is the difference between the Persistence rate to the last grade of primary education (%) in Eritrea and Persistence rate to the last grade of primary education (%) in Niger?
Your answer should be compact. 16.23. What is the ratio of the Persistence rate to the last grade of primary education (%) of Sub-Saharan Africa (all income levels) in 2003 to that in 2006?
Keep it short and to the point. 1.05. What is the ratio of the Persistence rate to the last grade of primary education (%) in Eritrea in 2003 to that in 2006?
Keep it short and to the point. 1.47. What is the ratio of the Persistence rate to the last grade of primary education (%) of Niger in 2003 to that in 2006?
Your answer should be compact. 0.97. What is the ratio of the Persistence rate to the last grade of primary education (%) of Euro area in 2003 to that in 2007?
Your answer should be very brief. 1.01. What is the ratio of the Persistence rate to the last grade of primary education (%) in Sub-Saharan Africa (all income levels) in 2003 to that in 2007?
Provide a short and direct response. 1.08. What is the ratio of the Persistence rate to the last grade of primary education (%) in Eritrea in 2003 to that in 2007?
Offer a very short reply. 1.12. What is the ratio of the Persistence rate to the last grade of primary education (%) in Niger in 2003 to that in 2007?
Give a very brief answer. 0.96. What is the ratio of the Persistence rate to the last grade of primary education (%) in Sub-Saharan Africa (all income levels) in 2003 to that in 2008?
Offer a very short reply. 1.04. What is the ratio of the Persistence rate to the last grade of primary education (%) in Eritrea in 2003 to that in 2008?
Your answer should be compact. 1.17. What is the ratio of the Persistence rate to the last grade of primary education (%) of Niger in 2003 to that in 2008?
Keep it short and to the point. 1.01. What is the ratio of the Persistence rate to the last grade of primary education (%) of Euro area in 2003 to that in 2009?
Give a very brief answer. 1.01. What is the ratio of the Persistence rate to the last grade of primary education (%) in Sub-Saharan Africa (all income levels) in 2003 to that in 2009?
Give a very brief answer. 1.07. What is the ratio of the Persistence rate to the last grade of primary education (%) in Eritrea in 2003 to that in 2009?
Provide a succinct answer. 1.22. What is the ratio of the Persistence rate to the last grade of primary education (%) of Niger in 2003 to that in 2009?
Your answer should be compact. 1.12. What is the ratio of the Persistence rate to the last grade of primary education (%) of Sub-Saharan Africa (all income levels) in 2003 to that in 2012?
Offer a terse response. 1.09. What is the ratio of the Persistence rate to the last grade of primary education (%) in Eritrea in 2003 to that in 2012?
Make the answer very short. 1.11. What is the ratio of the Persistence rate to the last grade of primary education (%) in Niger in 2003 to that in 2012?
Your response must be concise. 1.14. What is the ratio of the Persistence rate to the last grade of primary education (%) of Sub-Saharan Africa (all income levels) in 2006 to that in 2007?
Offer a very short reply. 1.03. What is the ratio of the Persistence rate to the last grade of primary education (%) in Eritrea in 2006 to that in 2007?
Provide a succinct answer. 0.76. What is the ratio of the Persistence rate to the last grade of primary education (%) in Euro area in 2006 to that in 2008?
Give a very brief answer. 1. What is the ratio of the Persistence rate to the last grade of primary education (%) of Eritrea in 2006 to that in 2008?
Your answer should be compact. 0.8. What is the ratio of the Persistence rate to the last grade of primary education (%) in Niger in 2006 to that in 2008?
Provide a short and direct response. 1.04. What is the ratio of the Persistence rate to the last grade of primary education (%) of Euro area in 2006 to that in 2009?
Offer a terse response. 1.01. What is the ratio of the Persistence rate to the last grade of primary education (%) of Sub-Saharan Africa (all income levels) in 2006 to that in 2009?
Offer a very short reply. 1.02. What is the ratio of the Persistence rate to the last grade of primary education (%) in Eritrea in 2006 to that in 2009?
Provide a succinct answer. 0.83. What is the ratio of the Persistence rate to the last grade of primary education (%) of Niger in 2006 to that in 2009?
Offer a very short reply. 1.15. What is the ratio of the Persistence rate to the last grade of primary education (%) in Sub-Saharan Africa (all income levels) in 2006 to that in 2012?
Offer a very short reply. 1.04. What is the ratio of the Persistence rate to the last grade of primary education (%) of Eritrea in 2006 to that in 2012?
Give a very brief answer. 0.76. What is the ratio of the Persistence rate to the last grade of primary education (%) of Niger in 2006 to that in 2012?
Offer a terse response. 1.17. What is the ratio of the Persistence rate to the last grade of primary education (%) of Euro area in 2007 to that in 2008?
Provide a succinct answer. 1. What is the ratio of the Persistence rate to the last grade of primary education (%) of Sub-Saharan Africa (all income levels) in 2007 to that in 2008?
Provide a short and direct response. 0.96. What is the ratio of the Persistence rate to the last grade of primary education (%) in Eritrea in 2007 to that in 2008?
Give a very brief answer. 1.05. What is the ratio of the Persistence rate to the last grade of primary education (%) of Niger in 2007 to that in 2008?
Make the answer very short. 1.05. What is the ratio of the Persistence rate to the last grade of primary education (%) in Euro area in 2007 to that in 2009?
Offer a very short reply. 1. What is the ratio of the Persistence rate to the last grade of primary education (%) in Eritrea in 2007 to that in 2009?
Your response must be concise. 1.09. What is the ratio of the Persistence rate to the last grade of primary education (%) in Niger in 2007 to that in 2009?
Offer a terse response. 1.16. What is the ratio of the Persistence rate to the last grade of primary education (%) in Sub-Saharan Africa (all income levels) in 2007 to that in 2012?
Your response must be concise. 1.01. What is the ratio of the Persistence rate to the last grade of primary education (%) in Eritrea in 2007 to that in 2012?
Keep it short and to the point. 0.99. What is the ratio of the Persistence rate to the last grade of primary education (%) in Niger in 2007 to that in 2012?
Provide a short and direct response. 1.18. What is the ratio of the Persistence rate to the last grade of primary education (%) in Sub-Saharan Africa (all income levels) in 2008 to that in 2009?
Keep it short and to the point. 1.04. What is the ratio of the Persistence rate to the last grade of primary education (%) in Eritrea in 2008 to that in 2009?
Offer a terse response. 1.04. What is the ratio of the Persistence rate to the last grade of primary education (%) of Niger in 2008 to that in 2009?
Offer a terse response. 1.11. What is the ratio of the Persistence rate to the last grade of primary education (%) of Euro area in 2008 to that in 2012?
Give a very brief answer. 1. What is the ratio of the Persistence rate to the last grade of primary education (%) of Sub-Saharan Africa (all income levels) in 2008 to that in 2012?
Offer a terse response. 1.05. What is the ratio of the Persistence rate to the last grade of primary education (%) in Eritrea in 2008 to that in 2012?
Ensure brevity in your answer.  0.95. What is the ratio of the Persistence rate to the last grade of primary education (%) of Niger in 2008 to that in 2012?
Ensure brevity in your answer.  1.12. What is the ratio of the Persistence rate to the last grade of primary education (%) in Sub-Saharan Africa (all income levels) in 2009 to that in 2012?
Provide a succinct answer. 1.02. What is the ratio of the Persistence rate to the last grade of primary education (%) in Eritrea in 2009 to that in 2012?
Make the answer very short. 0.91. What is the ratio of the Persistence rate to the last grade of primary education (%) of Niger in 2009 to that in 2012?
Provide a short and direct response. 1.02. What is the difference between the highest and the second highest Persistence rate to the last grade of primary education (%) of Euro area?
Offer a terse response. 0.35. What is the difference between the highest and the second highest Persistence rate to the last grade of primary education (%) of Sub-Saharan Africa (all income levels)?
Offer a very short reply. 2.27. What is the difference between the highest and the second highest Persistence rate to the last grade of primary education (%) of Eritrea?
Ensure brevity in your answer.  8.85. What is the difference between the highest and the second highest Persistence rate to the last grade of primary education (%) of Niger?
Keep it short and to the point. 0.84. What is the difference between the highest and the lowest Persistence rate to the last grade of primary education (%) in Euro area?
Ensure brevity in your answer.  1.06. What is the difference between the highest and the lowest Persistence rate to the last grade of primary education (%) in Sub-Saharan Africa (all income levels)?
Your response must be concise. 5.21. What is the difference between the highest and the lowest Persistence rate to the last grade of primary education (%) of Eritrea?
Ensure brevity in your answer.  27.73. What is the difference between the highest and the lowest Persistence rate to the last grade of primary education (%) of Niger?
Keep it short and to the point. 11.09. 